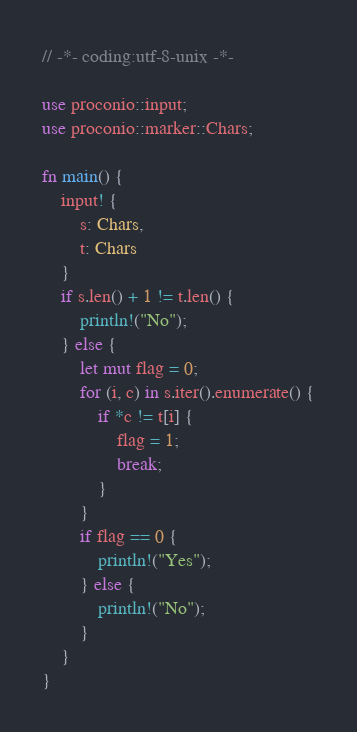<code> <loc_0><loc_0><loc_500><loc_500><_Rust_>// -*- coding:utf-8-unix -*-

use proconio::input;
use proconio::marker::Chars;

fn main() {
    input! {
        s: Chars,
        t: Chars
    }
    if s.len() + 1 != t.len() {
        println!("No");    
    } else {
        let mut flag = 0;
        for (i, c) in s.iter().enumerate() {
            if *c != t[i] {
                flag = 1;
                break;
            }
        }
        if flag == 0 {
            println!("Yes");
        } else {
            println!("No");
        }
    }
}
</code> 